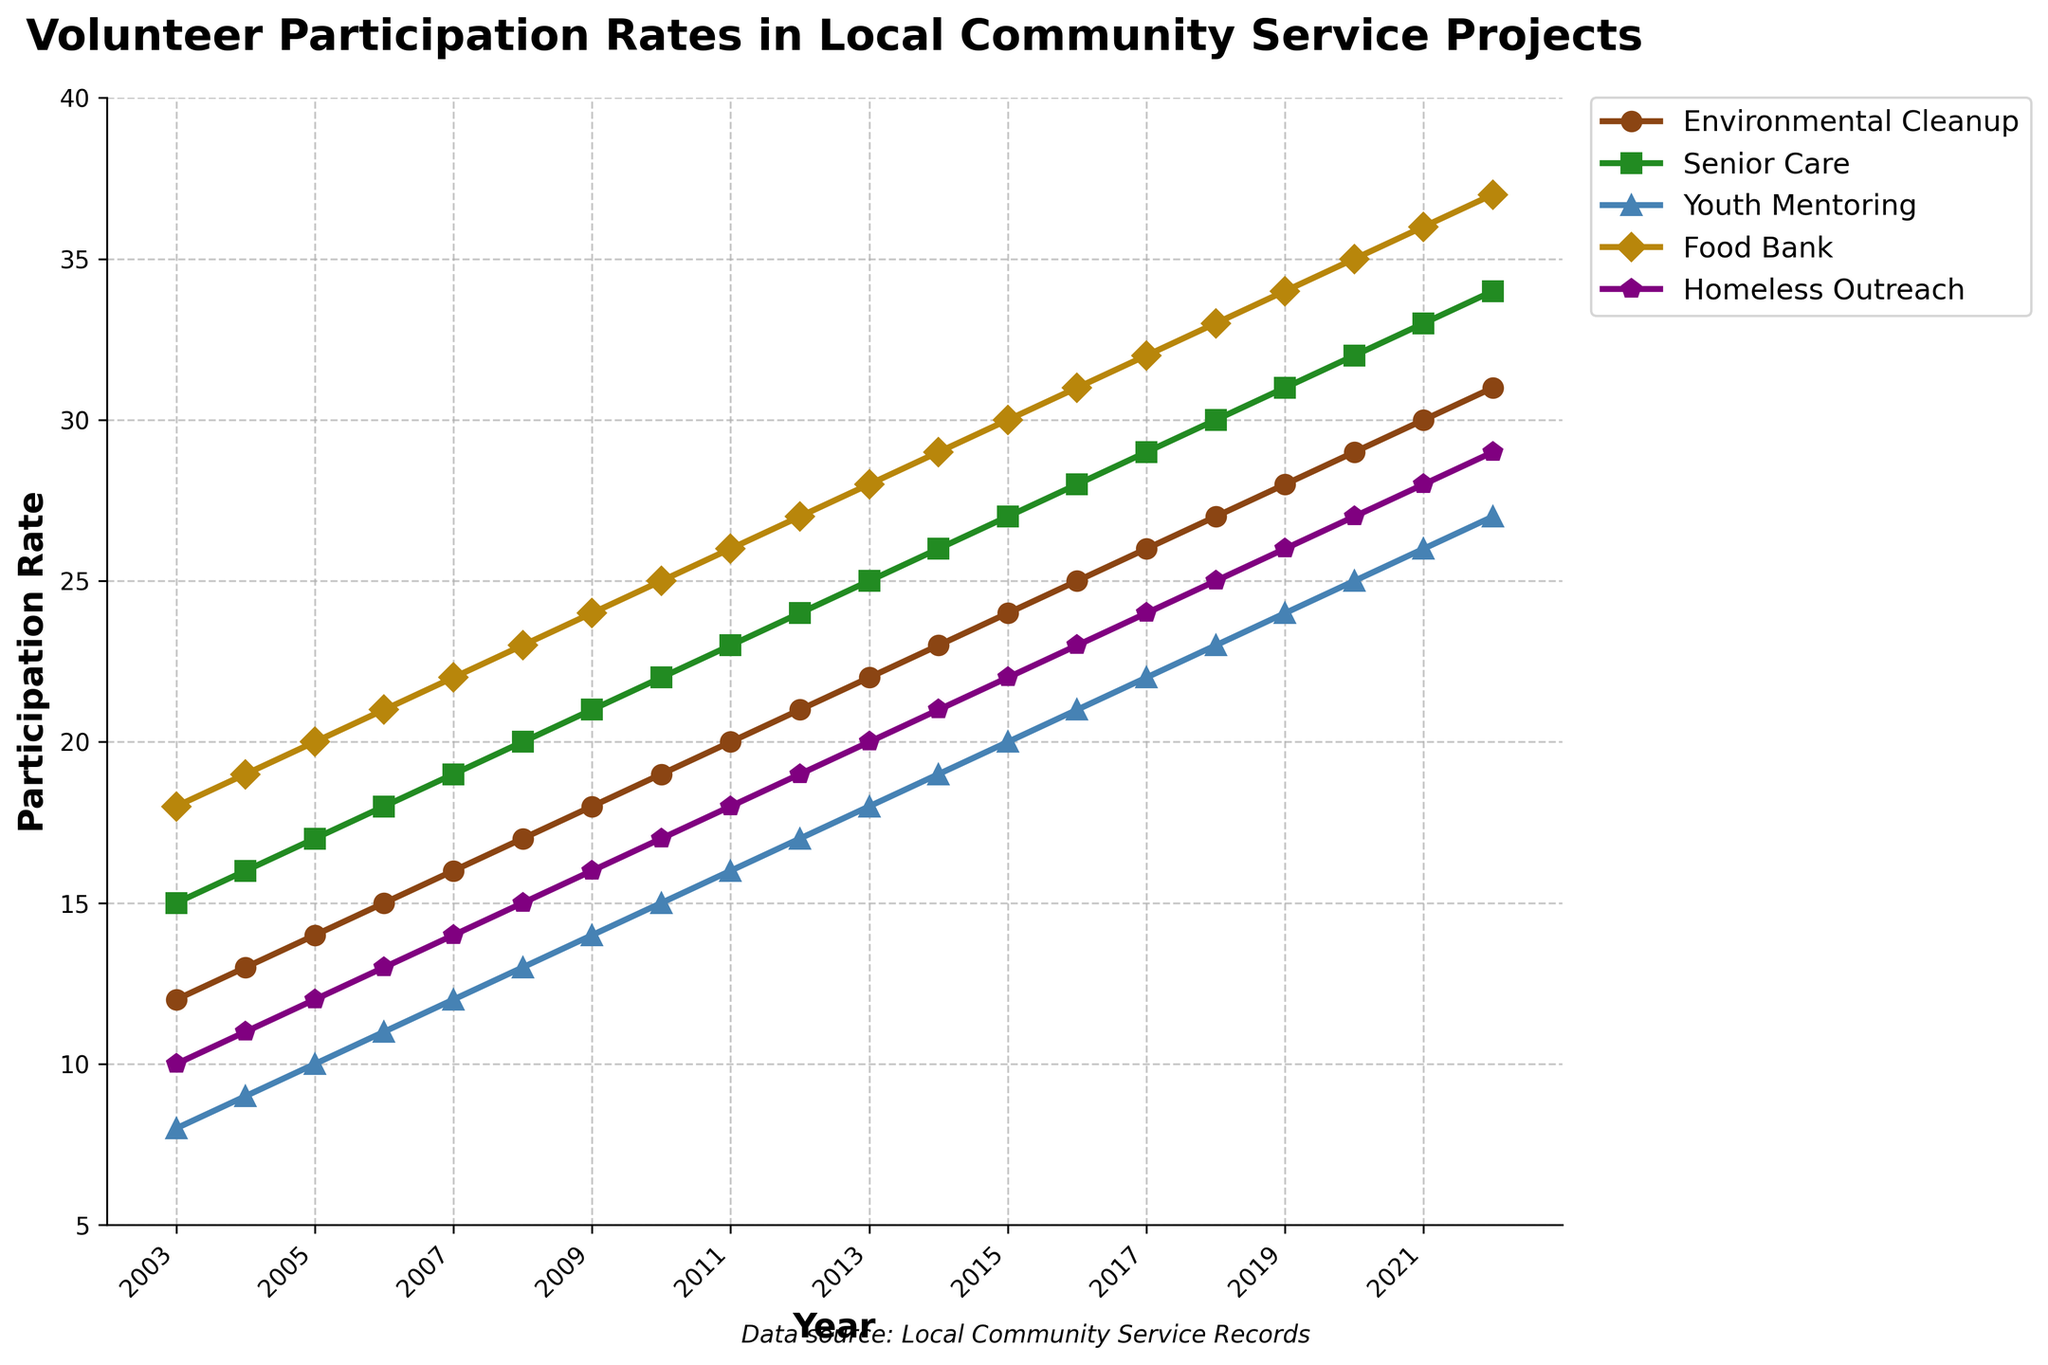How many more people participated in Food Bank activities in 2022 compared to 2003? To find the answer, subtract the participation rate in 2003 from the participation rate in 2022 for the Food Bank activity: 37 (2022) - 18 (2003).
Answer: 19 Which activity had the highest participation rate in 2022? Compare the participation rates of all activities in 2022. Environmental Cleanup: 31, Senior Care: 34, Youth Mentoring: 27, Food Bank: 37, Homeless Outreach: 29. The highest rate is for Food Bank.
Answer: Food Bank Between 2008 and 2012, which activity saw the greatest increase in participation rates? Calculate the difference in participation rates between 2008 and 2012 for each activity: Environmental Cleanup (21-17), Senior Care (24-20), Youth Mentoring (17-13), Food Bank (27-23), Homeless Outreach (19-15). The greatest increase is seen in Food Bank (4).
Answer: Food Bank In which year did Youth Mentoring first surpass 20% participation? Locate the first year on the graph where Youth Mentoring's participation rate is over 20%. This occurs in 2015.
Answer: 2015 What is the average participation rate for Senior Care activities over the last 20 years? Add up all the participation rates for Senior Care from 2003 to 2022 and divide by the number of years (20). (15+16+17+18+19+20+21+22+23+24+25+26+27+28+29+30+31+32+33+34)/20 = 24.5
Answer: 24.5 Which activity had the smallest increase in participation rates from 2003 to 2022? Calculate the increase for each activity and find the smallest one: Environmental Cleanup (31-12), Senior Care (34-15), Youth Mentoring (27-8), Food Bank (37-18), Homeless Outreach (29-10). The smallest increase is for Youth Mentoring (19).
Answer: Youth Mentoring What is the total number of participation rates combined for Environmental Cleanup and Homeless Outreach in 2010? Add the participation rates for Environmental Cleanup and Homeless Outreach in 2010: 19 (Environmental Cleanup) + 17 (Homeless Outreach).
Answer: 36 Which two activities had the closest participation rates in 2018? Compare the 2018 participation rates for each pair. Environmental Cleanup: 27, Senior Care: 30, Youth Mentoring: 23, Food Bank: 33, Homeless Outreach: 25. The closest rates are Environmental Cleanup and Homeless Outreach (27 and 25, respectively, difference of 2).
Answer: Environmental Cleanup and Homeless Outreach By how many percentage points did the participation rate in Senior Care increase from 2003 to 2010? Subtract the 2003 participation rate from the 2010 rate for Senior Care: 22 (2010) - 15 (2003).
Answer: 7 